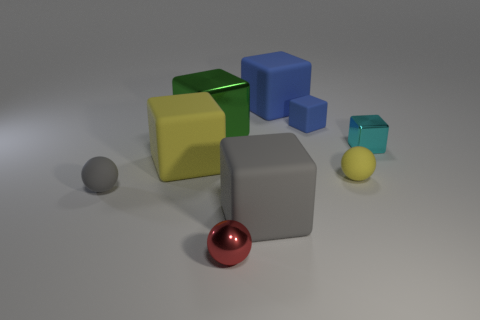The gray object to the left of the yellow matte object that is to the left of the small blue cube is what shape? The gray object located to the left of the yellow matte object, itself to the left of the small blue cube, is a sphere. Specifically, it's a small gray sphere with a smooth surface that reflects the surrounding light, indicating that it is likely a solid object made of a material such as metal or polished stone. 